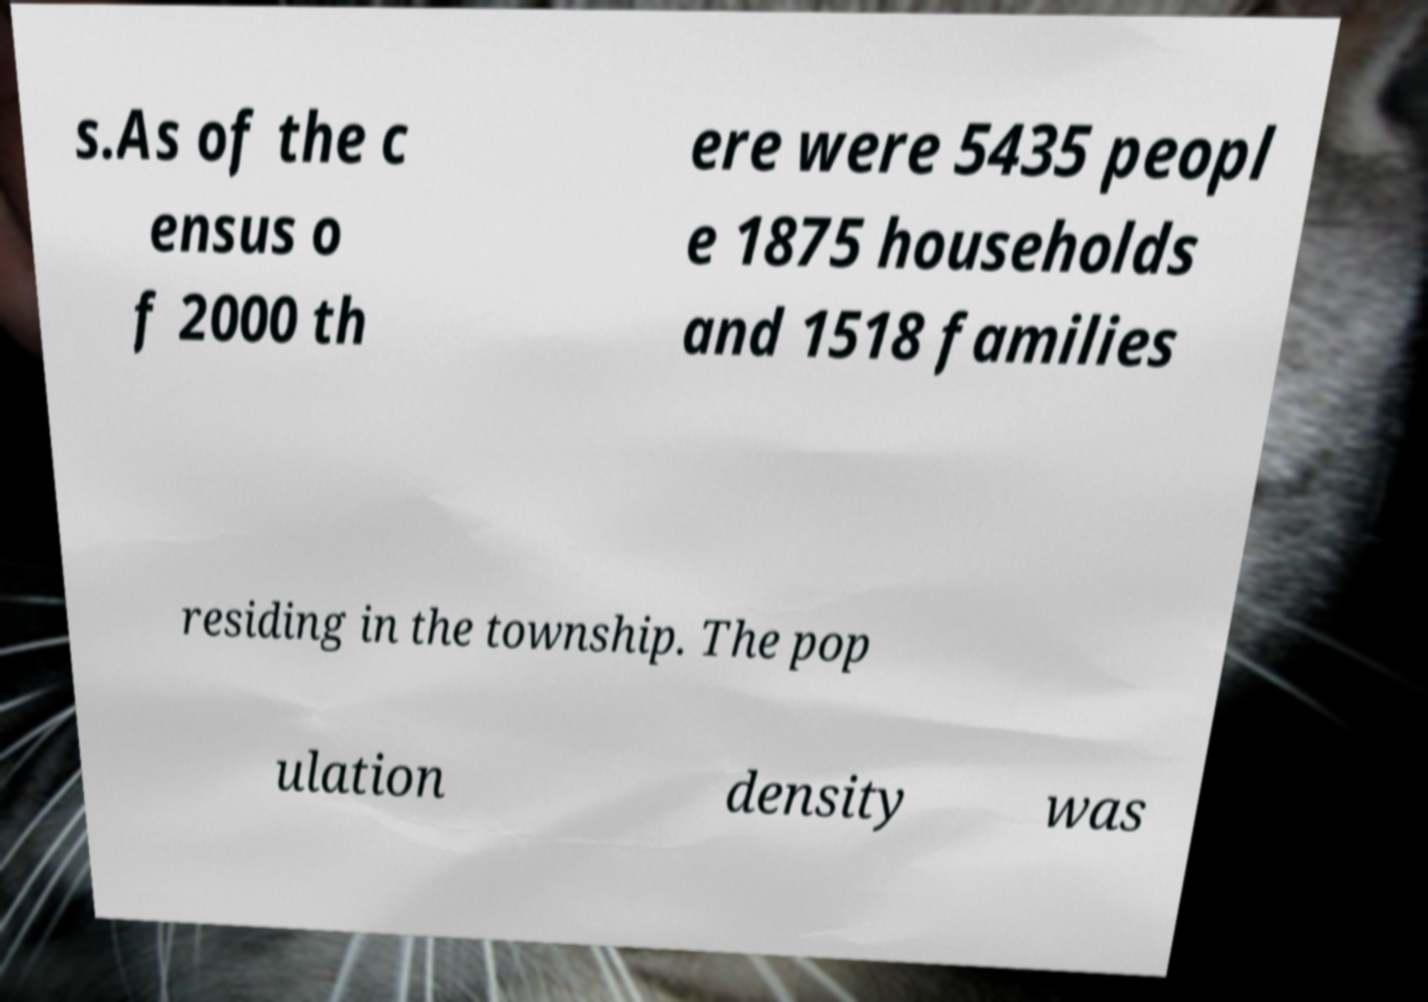There's text embedded in this image that I need extracted. Can you transcribe it verbatim? s.As of the c ensus o f 2000 th ere were 5435 peopl e 1875 households and 1518 families residing in the township. The pop ulation density was 